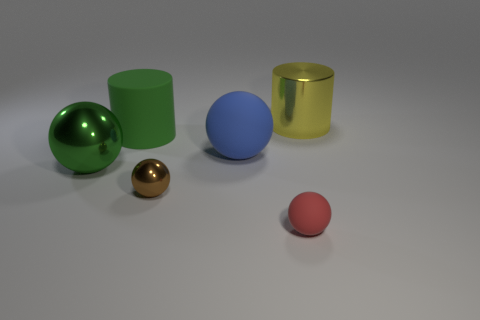Subtract 2 balls. How many balls are left? 2 Add 2 blue cylinders. How many objects exist? 8 Subtract all brown spheres. How many spheres are left? 3 Subtract all yellow spheres. Subtract all blue cubes. How many spheres are left? 4 Subtract all spheres. How many objects are left? 2 Subtract all cyan matte blocks. Subtract all brown metal spheres. How many objects are left? 5 Add 6 small things. How many small things are left? 8 Add 1 large green metal balls. How many large green metal balls exist? 2 Subtract 1 green cylinders. How many objects are left? 5 